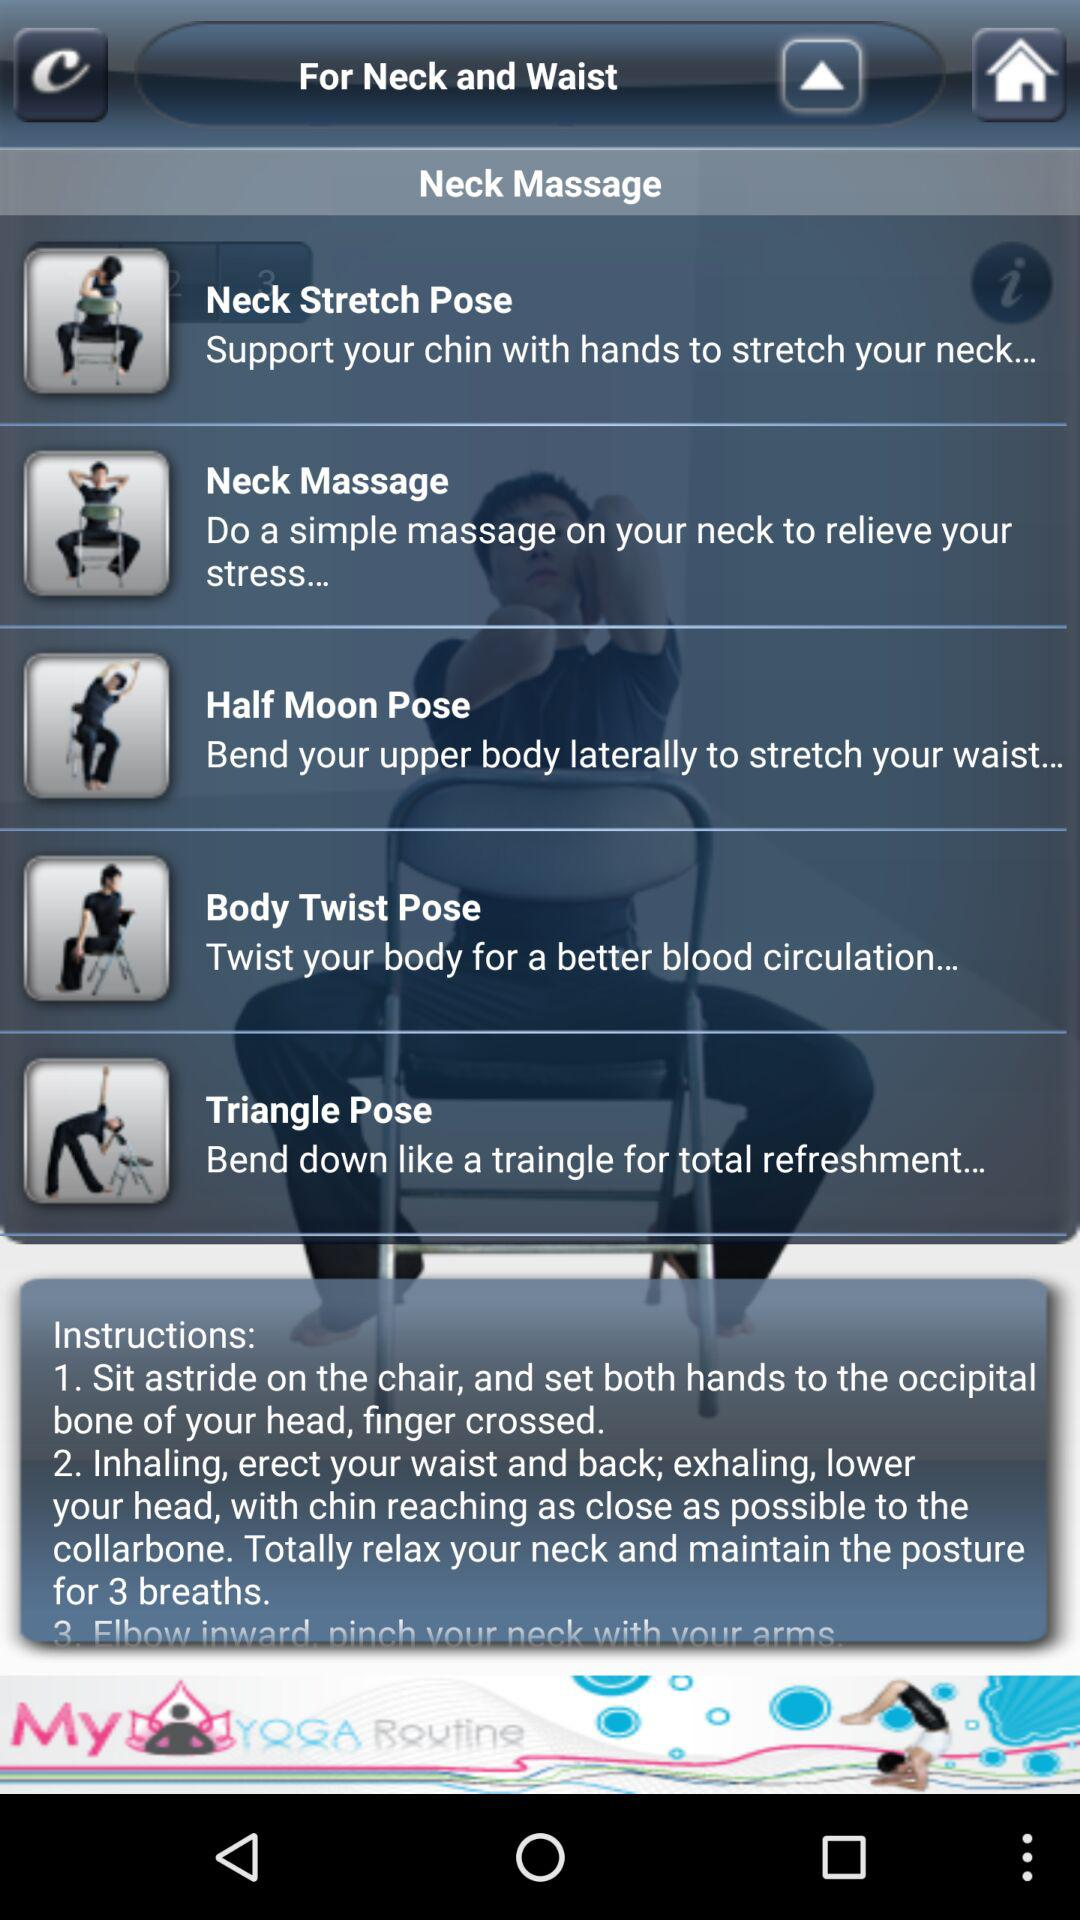What is the description of the "Body Twist Pose"? The description of the "Body Twist Pose" is "Twist your body for a better blood circulation...". 